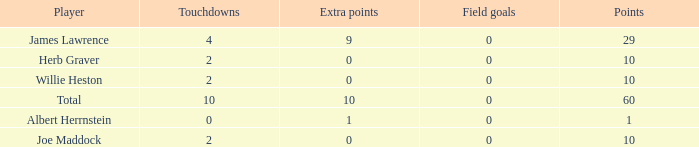What is the smallest number of field goals for players with 4 touchdowns and less than 9 extra points? None. 